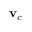<formula> <loc_0><loc_0><loc_500><loc_500>v _ { c }</formula> 